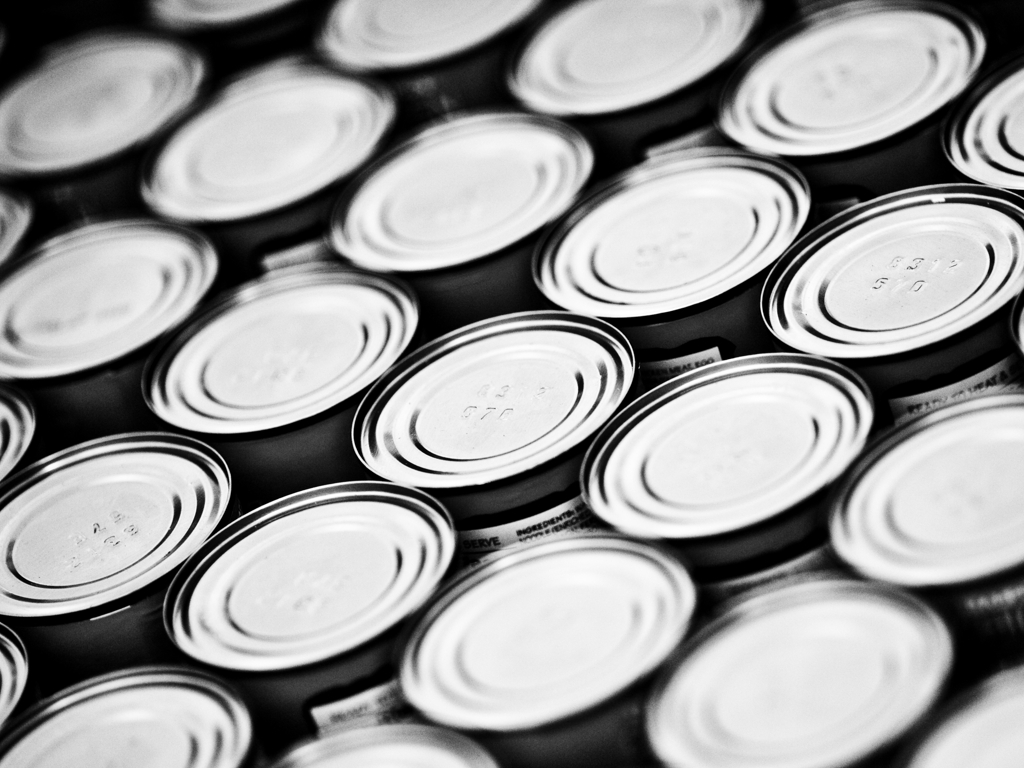Is there some blur around the edges?
A. No
B. Yes
Answer with the option's letter from the given choices directly.
 B. 